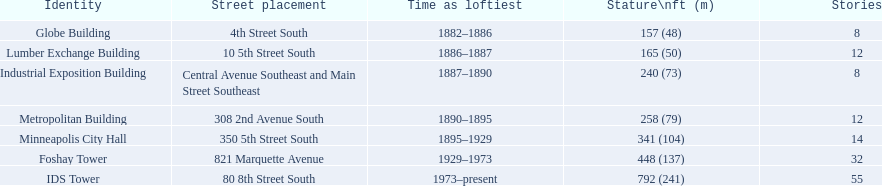How many floors does the lumber exchange building have? 12. What other building has 12 floors? Metropolitan Building. 